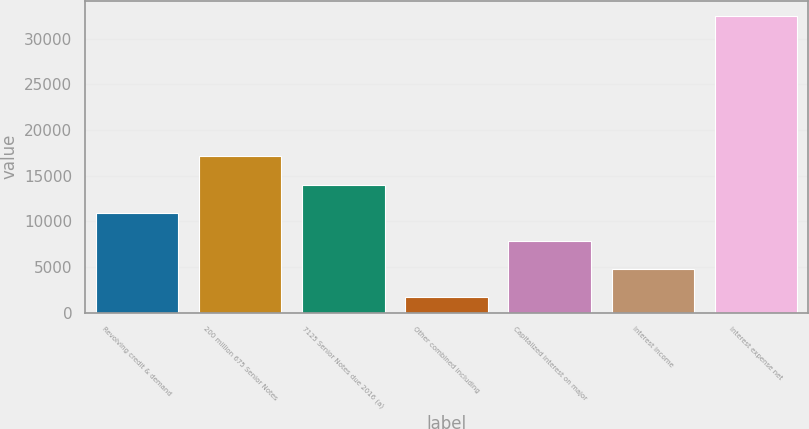<chart> <loc_0><loc_0><loc_500><loc_500><bar_chart><fcel>Revolving credit & demand<fcel>200 million 675 Senior Notes<fcel>7125 Senior Notes due 2016 (a)<fcel>Other combined including<fcel>Capitalized interest on major<fcel>Interest income<fcel>Interest expense net<nl><fcel>10934.3<fcel>17112.5<fcel>14023.4<fcel>1667<fcel>7845.2<fcel>4756.1<fcel>32558<nl></chart> 